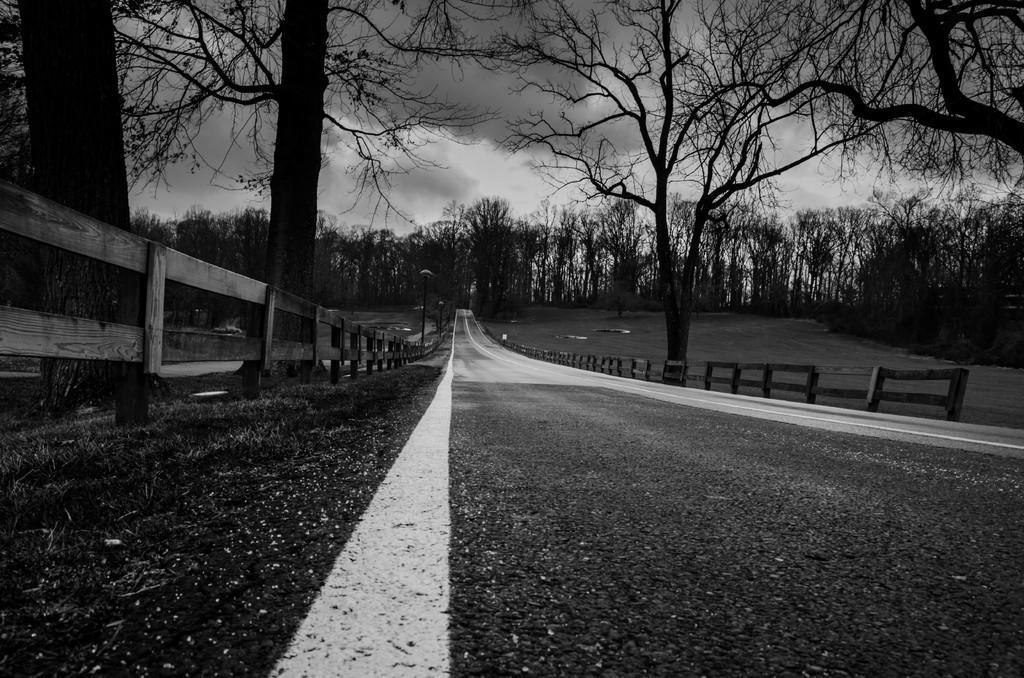How would you summarize this image in a sentence or two? This picture is clicked outside the city. Here, we see the road and on either side of the road, we see wooden fence and street lights. There are trees in the background and at the top of the picture, we see the sky. This is a black and white picture. 